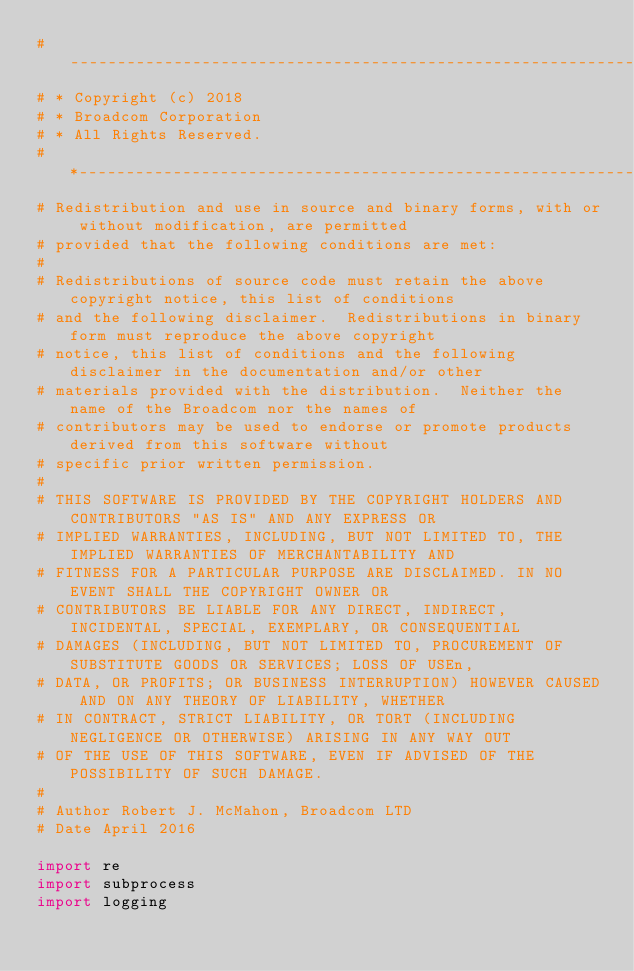<code> <loc_0><loc_0><loc_500><loc_500><_Python_># ----------------------------------------------------------------
# * Copyright (c) 2018
# * Broadcom Corporation
# * All Rights Reserved.
# *---------------------------------------------------------------
# Redistribution and use in source and binary forms, with or without modification, are permitted
# provided that the following conditions are met:
#
# Redistributions of source code must retain the above copyright notice, this list of conditions
# and the following disclaimer.  Redistributions in binary form must reproduce the above copyright
# notice, this list of conditions and the following disclaimer in the documentation and/or other
# materials provided with the distribution.  Neither the name of the Broadcom nor the names of
# contributors may be used to endorse or promote products derived from this software without
# specific prior written permission.
#
# THIS SOFTWARE IS PROVIDED BY THE COPYRIGHT HOLDERS AND CONTRIBUTORS "AS IS" AND ANY EXPRESS OR
# IMPLIED WARRANTIES, INCLUDING, BUT NOT LIMITED TO, THE IMPLIED WARRANTIES OF MERCHANTABILITY AND
# FITNESS FOR A PARTICULAR PURPOSE ARE DISCLAIMED. IN NO EVENT SHALL THE COPYRIGHT OWNER OR
# CONTRIBUTORS BE LIABLE FOR ANY DIRECT, INDIRECT, INCIDENTAL, SPECIAL, EXEMPLARY, OR CONSEQUENTIAL
# DAMAGES (INCLUDING, BUT NOT LIMITED TO, PROCUREMENT OF SUBSTITUTE GOODS OR SERVICES; LOSS OF USEn,
# DATA, OR PROFITS; OR BUSINESS INTERRUPTION) HOWEVER CAUSED AND ON ANY THEORY OF LIABILITY, WHETHER
# IN CONTRACT, STRICT LIABILITY, OR TORT (INCLUDING NEGLIGENCE OR OTHERWISE) ARISING IN ANY WAY OUT
# OF THE USE OF THIS SOFTWARE, EVEN IF ADVISED OF THE POSSIBILITY OF SUCH DAMAGE.
#
# Author Robert J. McMahon, Broadcom LTD
# Date April 2016

import re
import subprocess
import logging</code> 